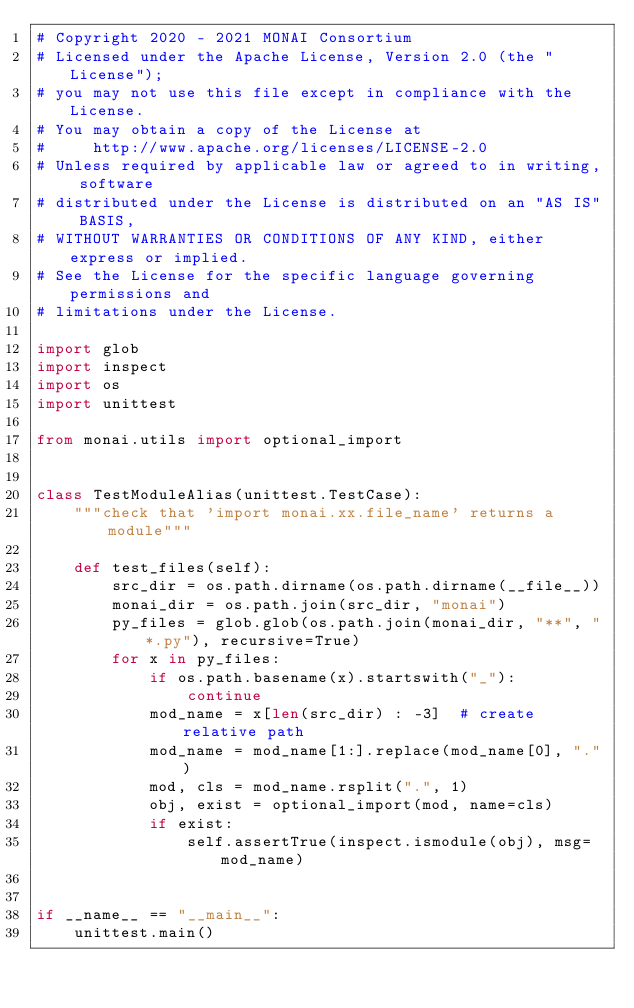Convert code to text. <code><loc_0><loc_0><loc_500><loc_500><_Python_># Copyright 2020 - 2021 MONAI Consortium
# Licensed under the Apache License, Version 2.0 (the "License");
# you may not use this file except in compliance with the License.
# You may obtain a copy of the License at
#     http://www.apache.org/licenses/LICENSE-2.0
# Unless required by applicable law or agreed to in writing, software
# distributed under the License is distributed on an "AS IS" BASIS,
# WITHOUT WARRANTIES OR CONDITIONS OF ANY KIND, either express or implied.
# See the License for the specific language governing permissions and
# limitations under the License.

import glob
import inspect
import os
import unittest

from monai.utils import optional_import


class TestModuleAlias(unittest.TestCase):
    """check that 'import monai.xx.file_name' returns a module"""

    def test_files(self):
        src_dir = os.path.dirname(os.path.dirname(__file__))
        monai_dir = os.path.join(src_dir, "monai")
        py_files = glob.glob(os.path.join(monai_dir, "**", "*.py"), recursive=True)
        for x in py_files:
            if os.path.basename(x).startswith("_"):
                continue
            mod_name = x[len(src_dir) : -3]  # create relative path
            mod_name = mod_name[1:].replace(mod_name[0], ".")
            mod, cls = mod_name.rsplit(".", 1)
            obj, exist = optional_import(mod, name=cls)
            if exist:
                self.assertTrue(inspect.ismodule(obj), msg=mod_name)


if __name__ == "__main__":
    unittest.main()
</code> 